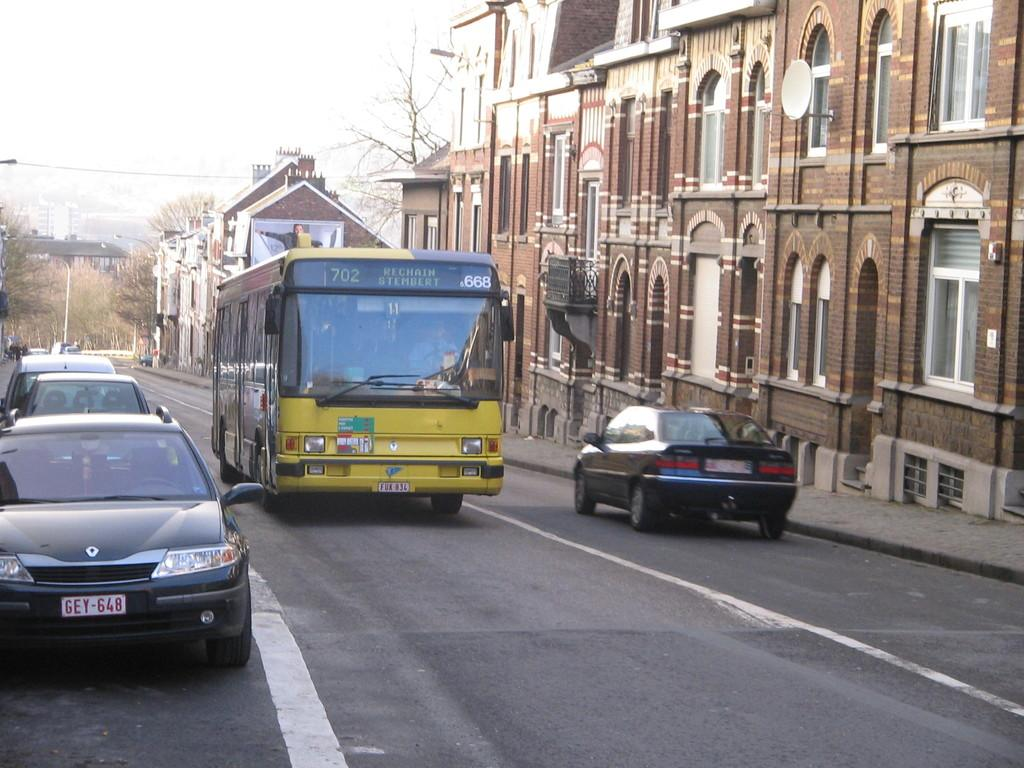Provide a one-sentence caption for the provided image. Bus that says Rechain Stembert at the top. 